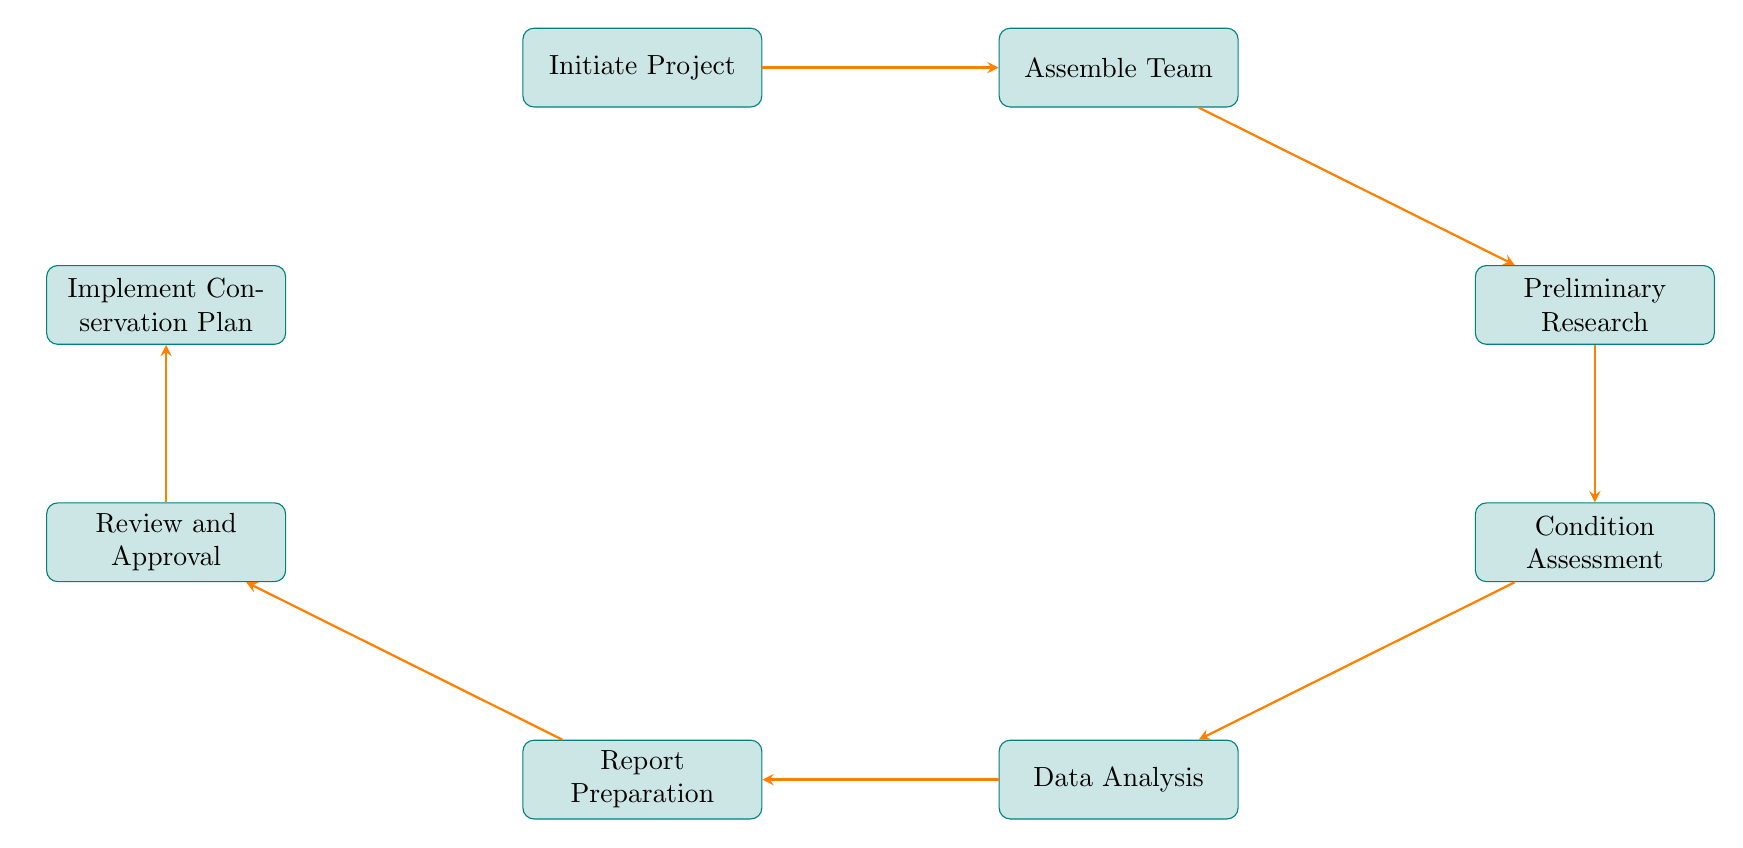What is the first step in the conservation condition survey process? The first step is indicated at the top of the flow chart and is labeled "Initiate Project." This step establishes the need for the survey.
Answer: Initiate Project How many steps are there in total in the flow chart? By counting each node in the diagram from "Initiate Project" to "Implement Conservation Plan," we find there are a total of eight steps.
Answer: Eight What is the last step in the conservation condition survey process? The last step is shown at the bottom of the flow chart and is labeled "Implement Conservation Plan," which signifies the execution of recommended actions.
Answer: Implement Conservation Plan What action follows the "Data Analysis" step? Looking at the arrows in the diagram, the next action following "Data Analysis" is "Report Preparation," indicating that data is compiled into a report.
Answer: Report Preparation What relationship exists between "Preliminary Research" and "Condition Assessment"? The relationship is a sequential progression indicated by the arrow connecting "Preliminary Research" to "Condition Assessment," meaning that after research, a condition assessment takes place.
Answer: Sequential progression Which step involves obtaining necessary approvals? The step related to approvals is explicitly labeled "Review and Approval," where the report is submitted for review and approvals from stakeholders.
Answer: Review and Approval What process comes before "Preliminary Research"? By tracing the arrows backward from "Preliminary Research," we find that the process that comes before it is "Assemble Team," which involves selecting professionals for the project.
Answer: Assemble Team How many arrows are used in the flow chart? Each connection between steps in the diagram is represented by an arrow, and by counting them, we see there are seven arrows indicating the direction of progress between the eight steps.
Answer: Seven 